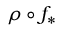Convert formula to latex. <formula><loc_0><loc_0><loc_500><loc_500>\rho \circ f _ { * }</formula> 